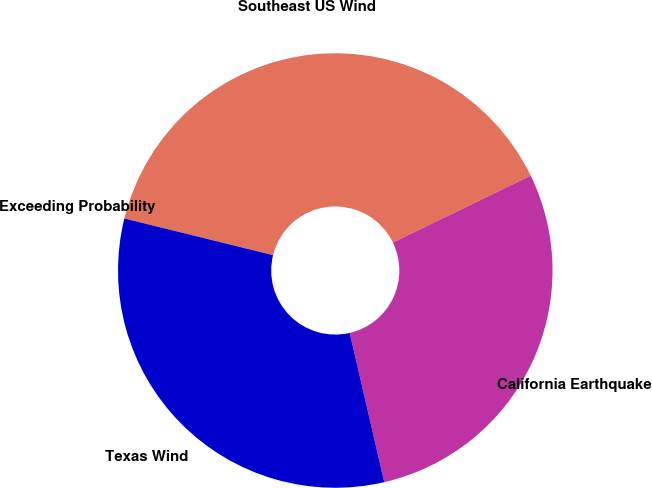<chart> <loc_0><loc_0><loc_500><loc_500><pie_chart><fcel>Exceeding Probability<fcel>Southeast US Wind<fcel>California Earthquake<fcel>Texas Wind<nl><fcel>0.0%<fcel>38.96%<fcel>28.57%<fcel>32.47%<nl></chart> 